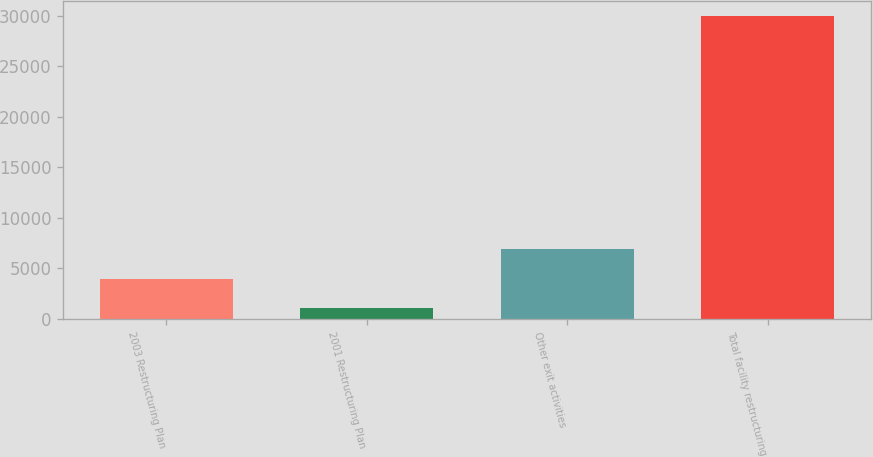<chart> <loc_0><loc_0><loc_500><loc_500><bar_chart><fcel>2003 Restructuring Plan<fcel>2001 Restructuring Plan<fcel>Other exit activities<fcel>Total facility restructuring<nl><fcel>3988.1<fcel>1096<fcel>6880.2<fcel>30017<nl></chart> 